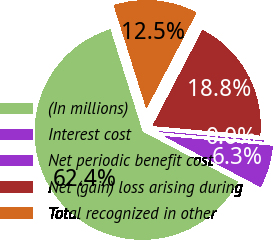<chart> <loc_0><loc_0><loc_500><loc_500><pie_chart><fcel>(In millions)<fcel>Interest cost<fcel>Net periodic benefit cost<fcel>Net (gain) loss arising during<fcel>Total recognized in other<nl><fcel>62.43%<fcel>6.27%<fcel>0.03%<fcel>18.75%<fcel>12.51%<nl></chart> 